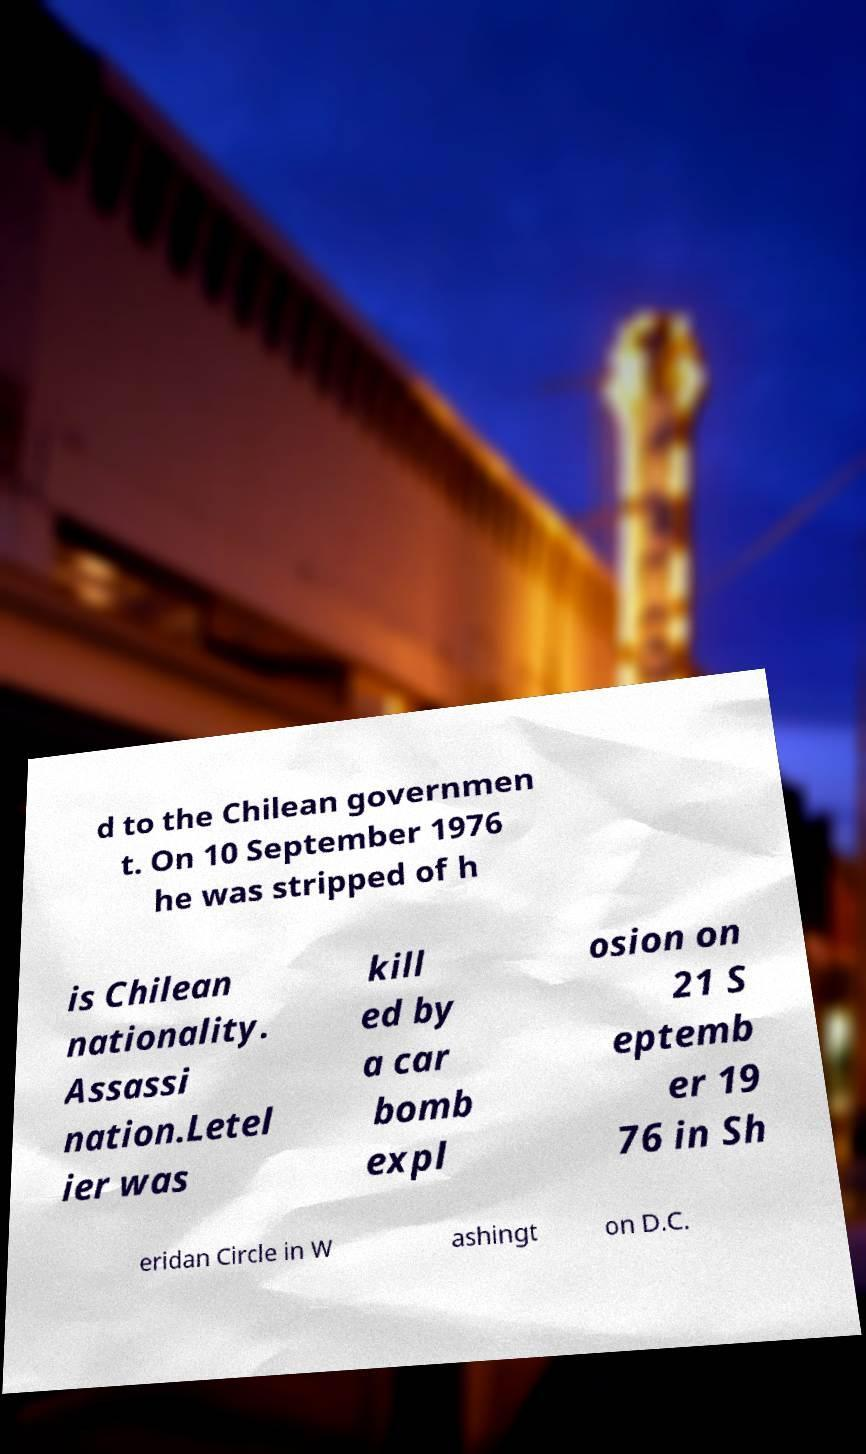Could you extract and type out the text from this image? d to the Chilean governmen t. On 10 September 1976 he was stripped of h is Chilean nationality. Assassi nation.Letel ier was kill ed by a car bomb expl osion on 21 S eptemb er 19 76 in Sh eridan Circle in W ashingt on D.C. 